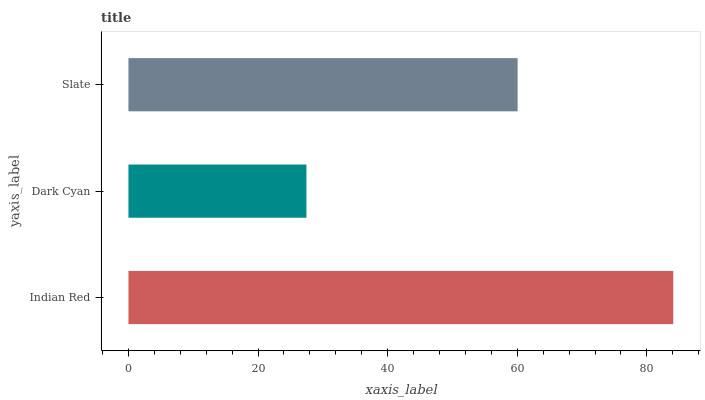Is Dark Cyan the minimum?
Answer yes or no. Yes. Is Indian Red the maximum?
Answer yes or no. Yes. Is Slate the minimum?
Answer yes or no. No. Is Slate the maximum?
Answer yes or no. No. Is Slate greater than Dark Cyan?
Answer yes or no. Yes. Is Dark Cyan less than Slate?
Answer yes or no. Yes. Is Dark Cyan greater than Slate?
Answer yes or no. No. Is Slate less than Dark Cyan?
Answer yes or no. No. Is Slate the high median?
Answer yes or no. Yes. Is Slate the low median?
Answer yes or no. Yes. Is Indian Red the high median?
Answer yes or no. No. Is Dark Cyan the low median?
Answer yes or no. No. 